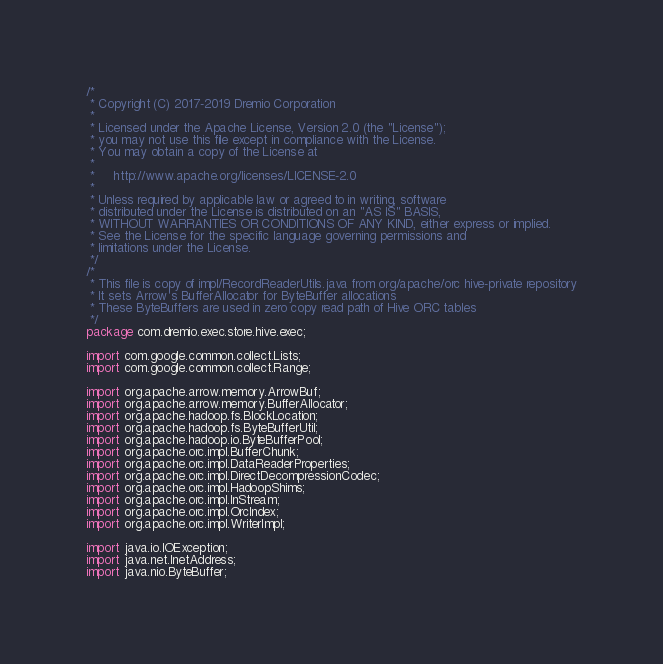<code> <loc_0><loc_0><loc_500><loc_500><_Java_>/*
 * Copyright (C) 2017-2019 Dremio Corporation
 *
 * Licensed under the Apache License, Version 2.0 (the "License");
 * you may not use this file except in compliance with the License.
 * You may obtain a copy of the License at
 *
 *     http://www.apache.org/licenses/LICENSE-2.0
 *
 * Unless required by applicable law or agreed to in writing, software
 * distributed under the License is distributed on an "AS IS" BASIS,
 * WITHOUT WARRANTIES OR CONDITIONS OF ANY KIND, either express or implied.
 * See the License for the specific language governing permissions and
 * limitations under the License.
 */
/*
 * This file is copy of impl/RecordReaderUtils.java from org/apache/orc hive-private repository
 * It sets Arrow's BufferAllocator for ByteBuffer allocations
 * These ByteBuffers are used in zero copy read path of Hive ORC tables
 */
package com.dremio.exec.store.hive.exec;

import com.google.common.collect.Lists;
import com.google.common.collect.Range;

import org.apache.arrow.memory.ArrowBuf;
import org.apache.arrow.memory.BufferAllocator;
import org.apache.hadoop.fs.BlockLocation;
import org.apache.hadoop.fs.ByteBufferUtil;
import org.apache.hadoop.io.ByteBufferPool;
import org.apache.orc.impl.BufferChunk;
import org.apache.orc.impl.DataReaderProperties;
import org.apache.orc.impl.DirectDecompressionCodec;
import org.apache.orc.impl.HadoopShims;
import org.apache.orc.impl.InStream;
import org.apache.orc.impl.OrcIndex;
import org.apache.orc.impl.WriterImpl;

import java.io.IOException;
import java.net.InetAddress;
import java.nio.ByteBuffer;</code> 